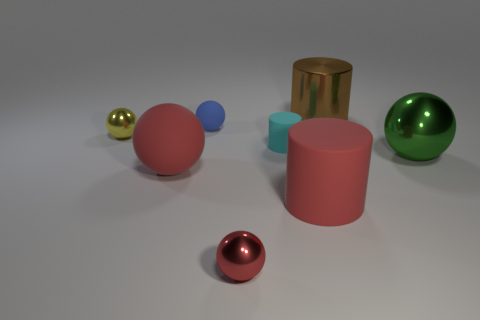How many large metal things have the same shape as the small cyan thing?
Offer a very short reply. 1. There is another rubber object that is the same size as the blue object; what color is it?
Provide a succinct answer. Cyan. Is the number of green spheres left of the red metallic object the same as the number of green spheres that are left of the blue ball?
Offer a terse response. Yes. Is there a red sphere of the same size as the cyan rubber object?
Provide a succinct answer. Yes. What size is the yellow metallic sphere?
Give a very brief answer. Small. Are there an equal number of metal spheres that are in front of the large red sphere and small red matte objects?
Ensure brevity in your answer.  No. What number of other things are the same color as the small cylinder?
Give a very brief answer. 0. What color is the metal thing that is right of the tiny yellow metal thing and to the left of the small cyan thing?
Ensure brevity in your answer.  Red. There is a object that is to the right of the cylinder that is behind the small metallic ball that is behind the green metal thing; what size is it?
Give a very brief answer. Large. How many things are either red matte things to the right of the red metallic ball or balls that are in front of the tiny yellow metallic sphere?
Make the answer very short. 4. 